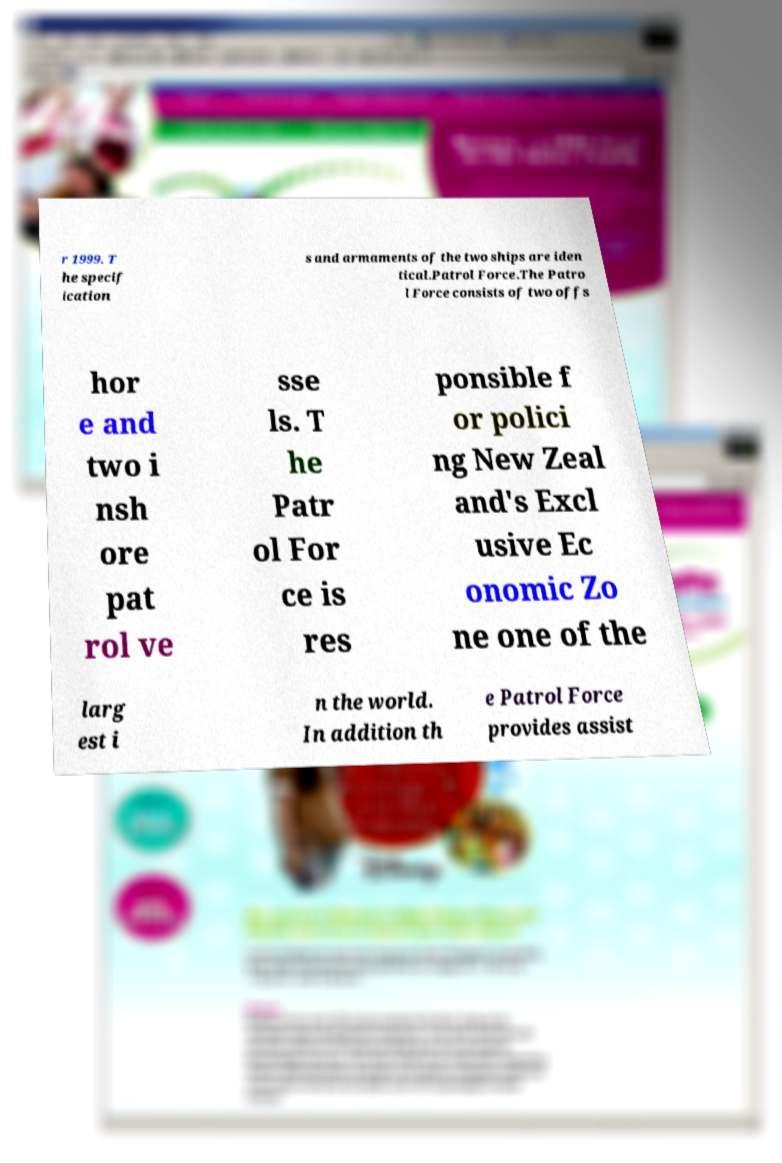Can you read and provide the text displayed in the image?This photo seems to have some interesting text. Can you extract and type it out for me? r 1999. T he specif ication s and armaments of the two ships are iden tical.Patrol Force.The Patro l Force consists of two offs hor e and two i nsh ore pat rol ve sse ls. T he Patr ol For ce is res ponsible f or polici ng New Zeal and's Excl usive Ec onomic Zo ne one of the larg est i n the world. In addition th e Patrol Force provides assist 